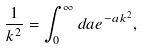Convert formula to latex. <formula><loc_0><loc_0><loc_500><loc_500>\frac { 1 } { k ^ { 2 } } = \int _ { 0 } ^ { \infty } d a e ^ { - a k ^ { 2 } } ,</formula> 